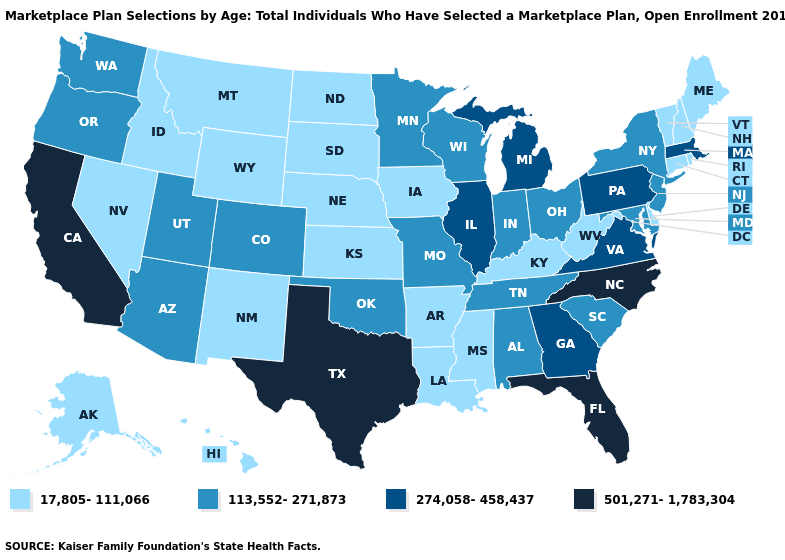What is the highest value in the MidWest ?
Write a very short answer. 274,058-458,437. Among the states that border Kentucky , does West Virginia have the highest value?
Quick response, please. No. Name the states that have a value in the range 17,805-111,066?
Keep it brief. Alaska, Arkansas, Connecticut, Delaware, Hawaii, Idaho, Iowa, Kansas, Kentucky, Louisiana, Maine, Mississippi, Montana, Nebraska, Nevada, New Hampshire, New Mexico, North Dakota, Rhode Island, South Dakota, Vermont, West Virginia, Wyoming. Name the states that have a value in the range 274,058-458,437?
Answer briefly. Georgia, Illinois, Massachusetts, Michigan, Pennsylvania, Virginia. Does Pennsylvania have the same value as Indiana?
Answer briefly. No. Is the legend a continuous bar?
Keep it brief. No. Which states hav the highest value in the West?
Short answer required. California. What is the highest value in states that border Arizona?
Be succinct. 501,271-1,783,304. Name the states that have a value in the range 113,552-271,873?
Write a very short answer. Alabama, Arizona, Colorado, Indiana, Maryland, Minnesota, Missouri, New Jersey, New York, Ohio, Oklahoma, Oregon, South Carolina, Tennessee, Utah, Washington, Wisconsin. Name the states that have a value in the range 17,805-111,066?
Answer briefly. Alaska, Arkansas, Connecticut, Delaware, Hawaii, Idaho, Iowa, Kansas, Kentucky, Louisiana, Maine, Mississippi, Montana, Nebraska, Nevada, New Hampshire, New Mexico, North Dakota, Rhode Island, South Dakota, Vermont, West Virginia, Wyoming. Name the states that have a value in the range 17,805-111,066?
Give a very brief answer. Alaska, Arkansas, Connecticut, Delaware, Hawaii, Idaho, Iowa, Kansas, Kentucky, Louisiana, Maine, Mississippi, Montana, Nebraska, Nevada, New Hampshire, New Mexico, North Dakota, Rhode Island, South Dakota, Vermont, West Virginia, Wyoming. What is the value of Arizona?
Keep it brief. 113,552-271,873. Which states have the lowest value in the MidWest?
Concise answer only. Iowa, Kansas, Nebraska, North Dakota, South Dakota. Name the states that have a value in the range 17,805-111,066?
Concise answer only. Alaska, Arkansas, Connecticut, Delaware, Hawaii, Idaho, Iowa, Kansas, Kentucky, Louisiana, Maine, Mississippi, Montana, Nebraska, Nevada, New Hampshire, New Mexico, North Dakota, Rhode Island, South Dakota, Vermont, West Virginia, Wyoming. Which states have the highest value in the USA?
Be succinct. California, Florida, North Carolina, Texas. 